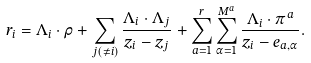Convert formula to latex. <formula><loc_0><loc_0><loc_500><loc_500>r _ { i } = \Lambda _ { i } \cdot \rho + \sum _ { j ( \neq i ) } \frac { \Lambda _ { i } \cdot \Lambda _ { j } } { z _ { i } - z _ { j } } + \sum _ { a = 1 } ^ { r } \sum _ { \alpha = 1 } ^ { M ^ { a } } \frac { \Lambda _ { i } \cdot \pi ^ { a } } { z _ { i } - e _ { a , \alpha } } .</formula> 